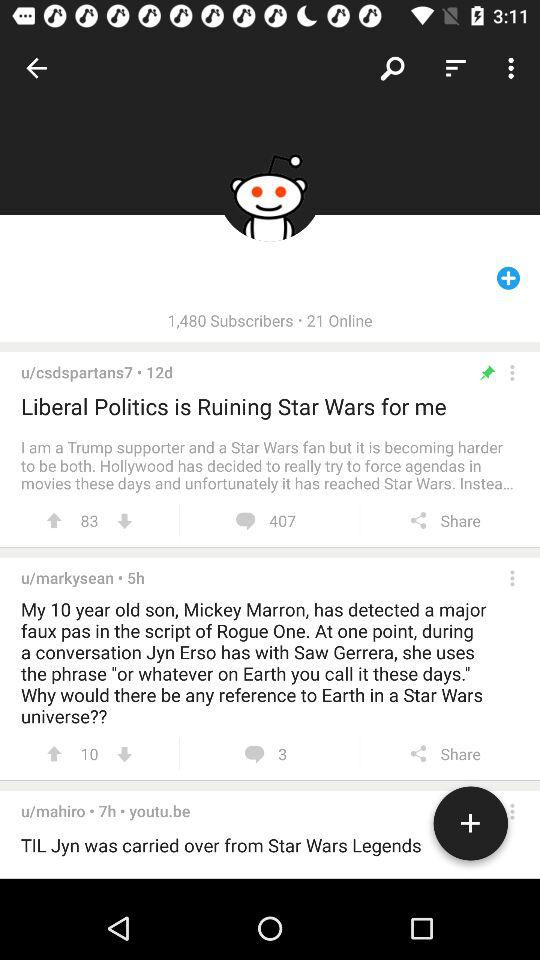How many subscribers are there? There are 1,480 subscribers. 